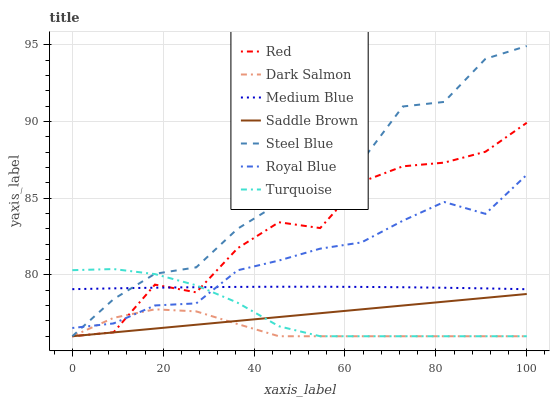Does Medium Blue have the minimum area under the curve?
Answer yes or no. No. Does Medium Blue have the maximum area under the curve?
Answer yes or no. No. Is Medium Blue the smoothest?
Answer yes or no. No. Is Medium Blue the roughest?
Answer yes or no. No. Does Medium Blue have the lowest value?
Answer yes or no. No. Does Medium Blue have the highest value?
Answer yes or no. No. Is Dark Salmon less than Medium Blue?
Answer yes or no. Yes. Is Medium Blue greater than Saddle Brown?
Answer yes or no. Yes. Does Dark Salmon intersect Medium Blue?
Answer yes or no. No. 